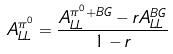Convert formula to latex. <formula><loc_0><loc_0><loc_500><loc_500>A _ { L L } ^ { \pi ^ { 0 } } = \frac { A _ { L L } ^ { \pi ^ { 0 } + { B G } } - r A _ { L L } ^ { B G } } { 1 - r }</formula> 